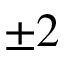<formula> <loc_0><loc_0><loc_500><loc_500>\pm 2</formula> 